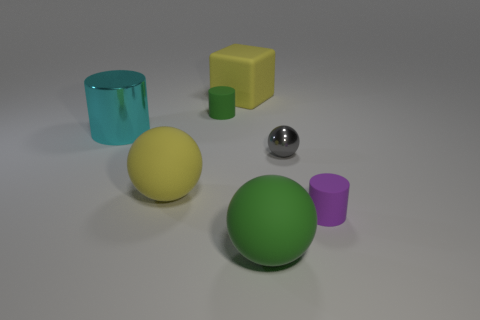The other small matte thing that is the same shape as the tiny purple matte thing is what color?
Provide a succinct answer. Green. Are there any small gray metal things on the left side of the big object in front of the tiny rubber cylinder that is in front of the large metallic object?
Offer a very short reply. No. Does the gray object have the same shape as the purple thing?
Keep it short and to the point. No. Are there fewer gray things that are in front of the big green rubber object than yellow things?
Ensure brevity in your answer.  Yes. There is a large ball that is behind the tiny rubber cylinder that is to the right of the big green rubber thing to the right of the big cube; what color is it?
Provide a short and direct response. Yellow. What number of matte things are either yellow things or cubes?
Your response must be concise. 2. Is the cyan object the same size as the purple rubber cylinder?
Make the answer very short. No. Are there fewer metallic balls to the left of the green ball than small purple rubber things that are behind the big metallic cylinder?
Your answer should be very brief. No. Is there anything else that has the same size as the gray metallic thing?
Your answer should be compact. Yes. The gray metal object has what size?
Provide a succinct answer. Small. 